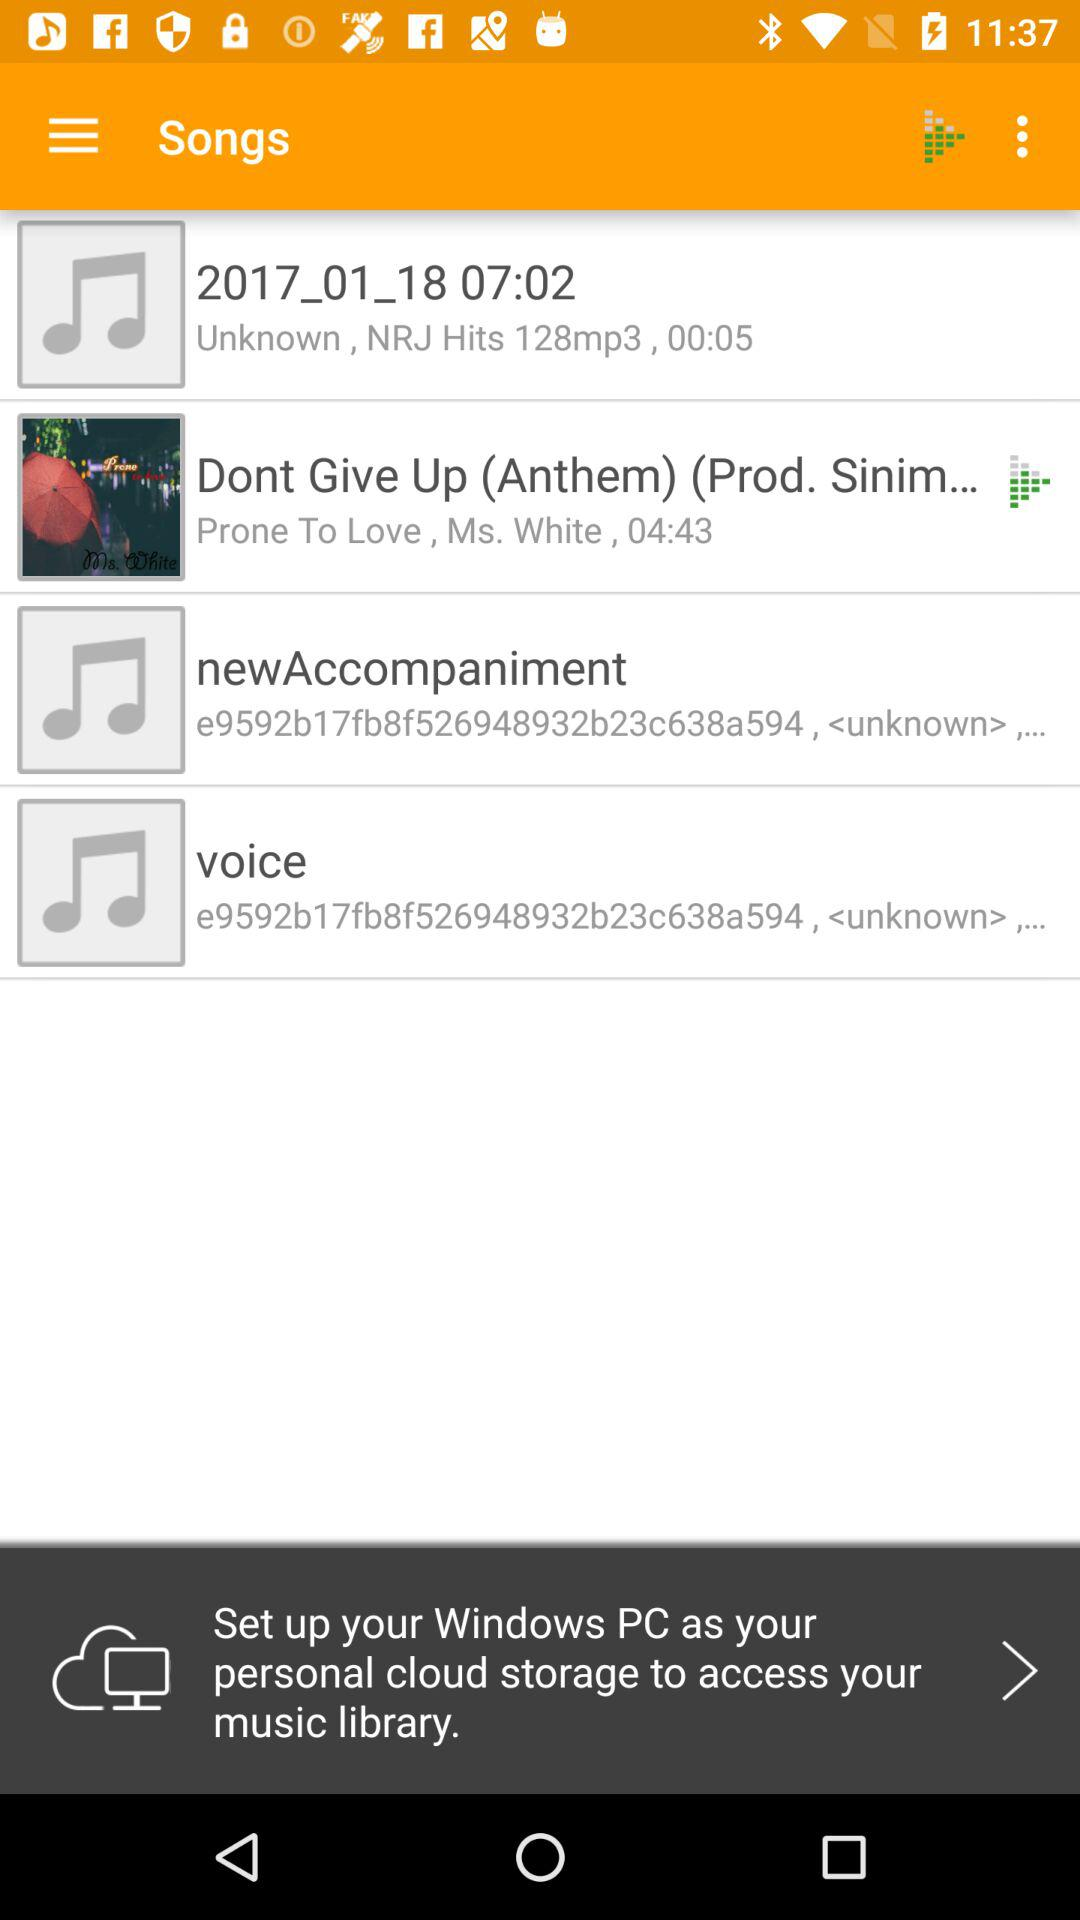What audio is 5 seconds long? The audio is 2017_01_18 07:02. 